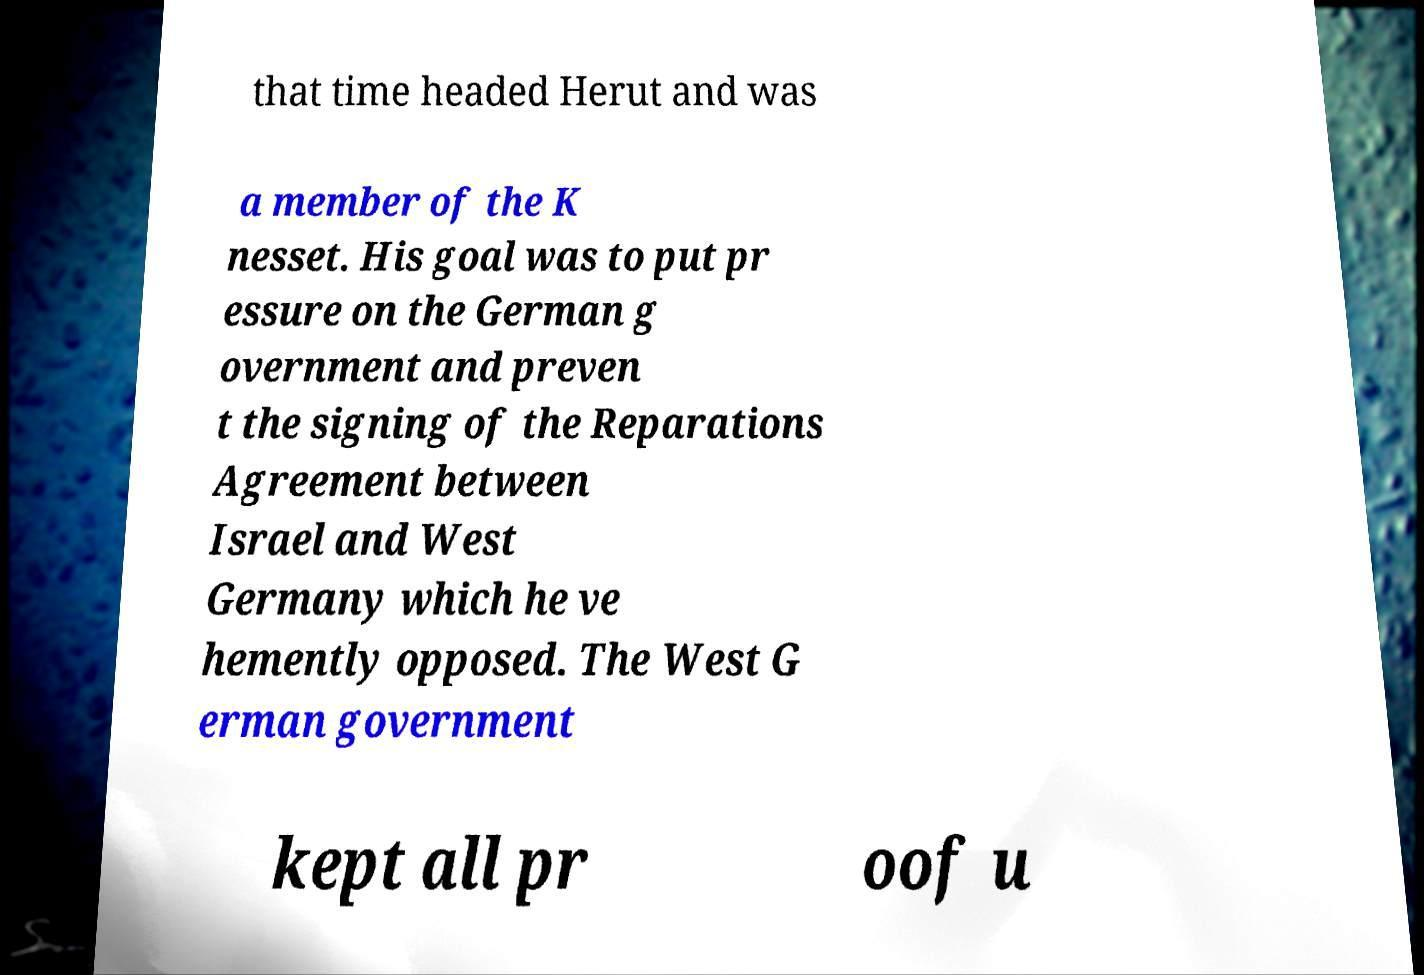I need the written content from this picture converted into text. Can you do that? that time headed Herut and was a member of the K nesset. His goal was to put pr essure on the German g overnment and preven t the signing of the Reparations Agreement between Israel and West Germany which he ve hemently opposed. The West G erman government kept all pr oof u 